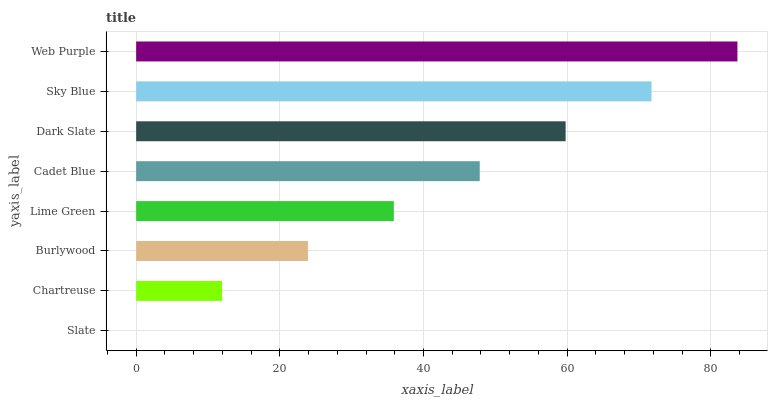Is Slate the minimum?
Answer yes or no. Yes. Is Web Purple the maximum?
Answer yes or no. Yes. Is Chartreuse the minimum?
Answer yes or no. No. Is Chartreuse the maximum?
Answer yes or no. No. Is Chartreuse greater than Slate?
Answer yes or no. Yes. Is Slate less than Chartreuse?
Answer yes or no. Yes. Is Slate greater than Chartreuse?
Answer yes or no. No. Is Chartreuse less than Slate?
Answer yes or no. No. Is Cadet Blue the high median?
Answer yes or no. Yes. Is Lime Green the low median?
Answer yes or no. Yes. Is Chartreuse the high median?
Answer yes or no. No. Is Burlywood the low median?
Answer yes or no. No. 